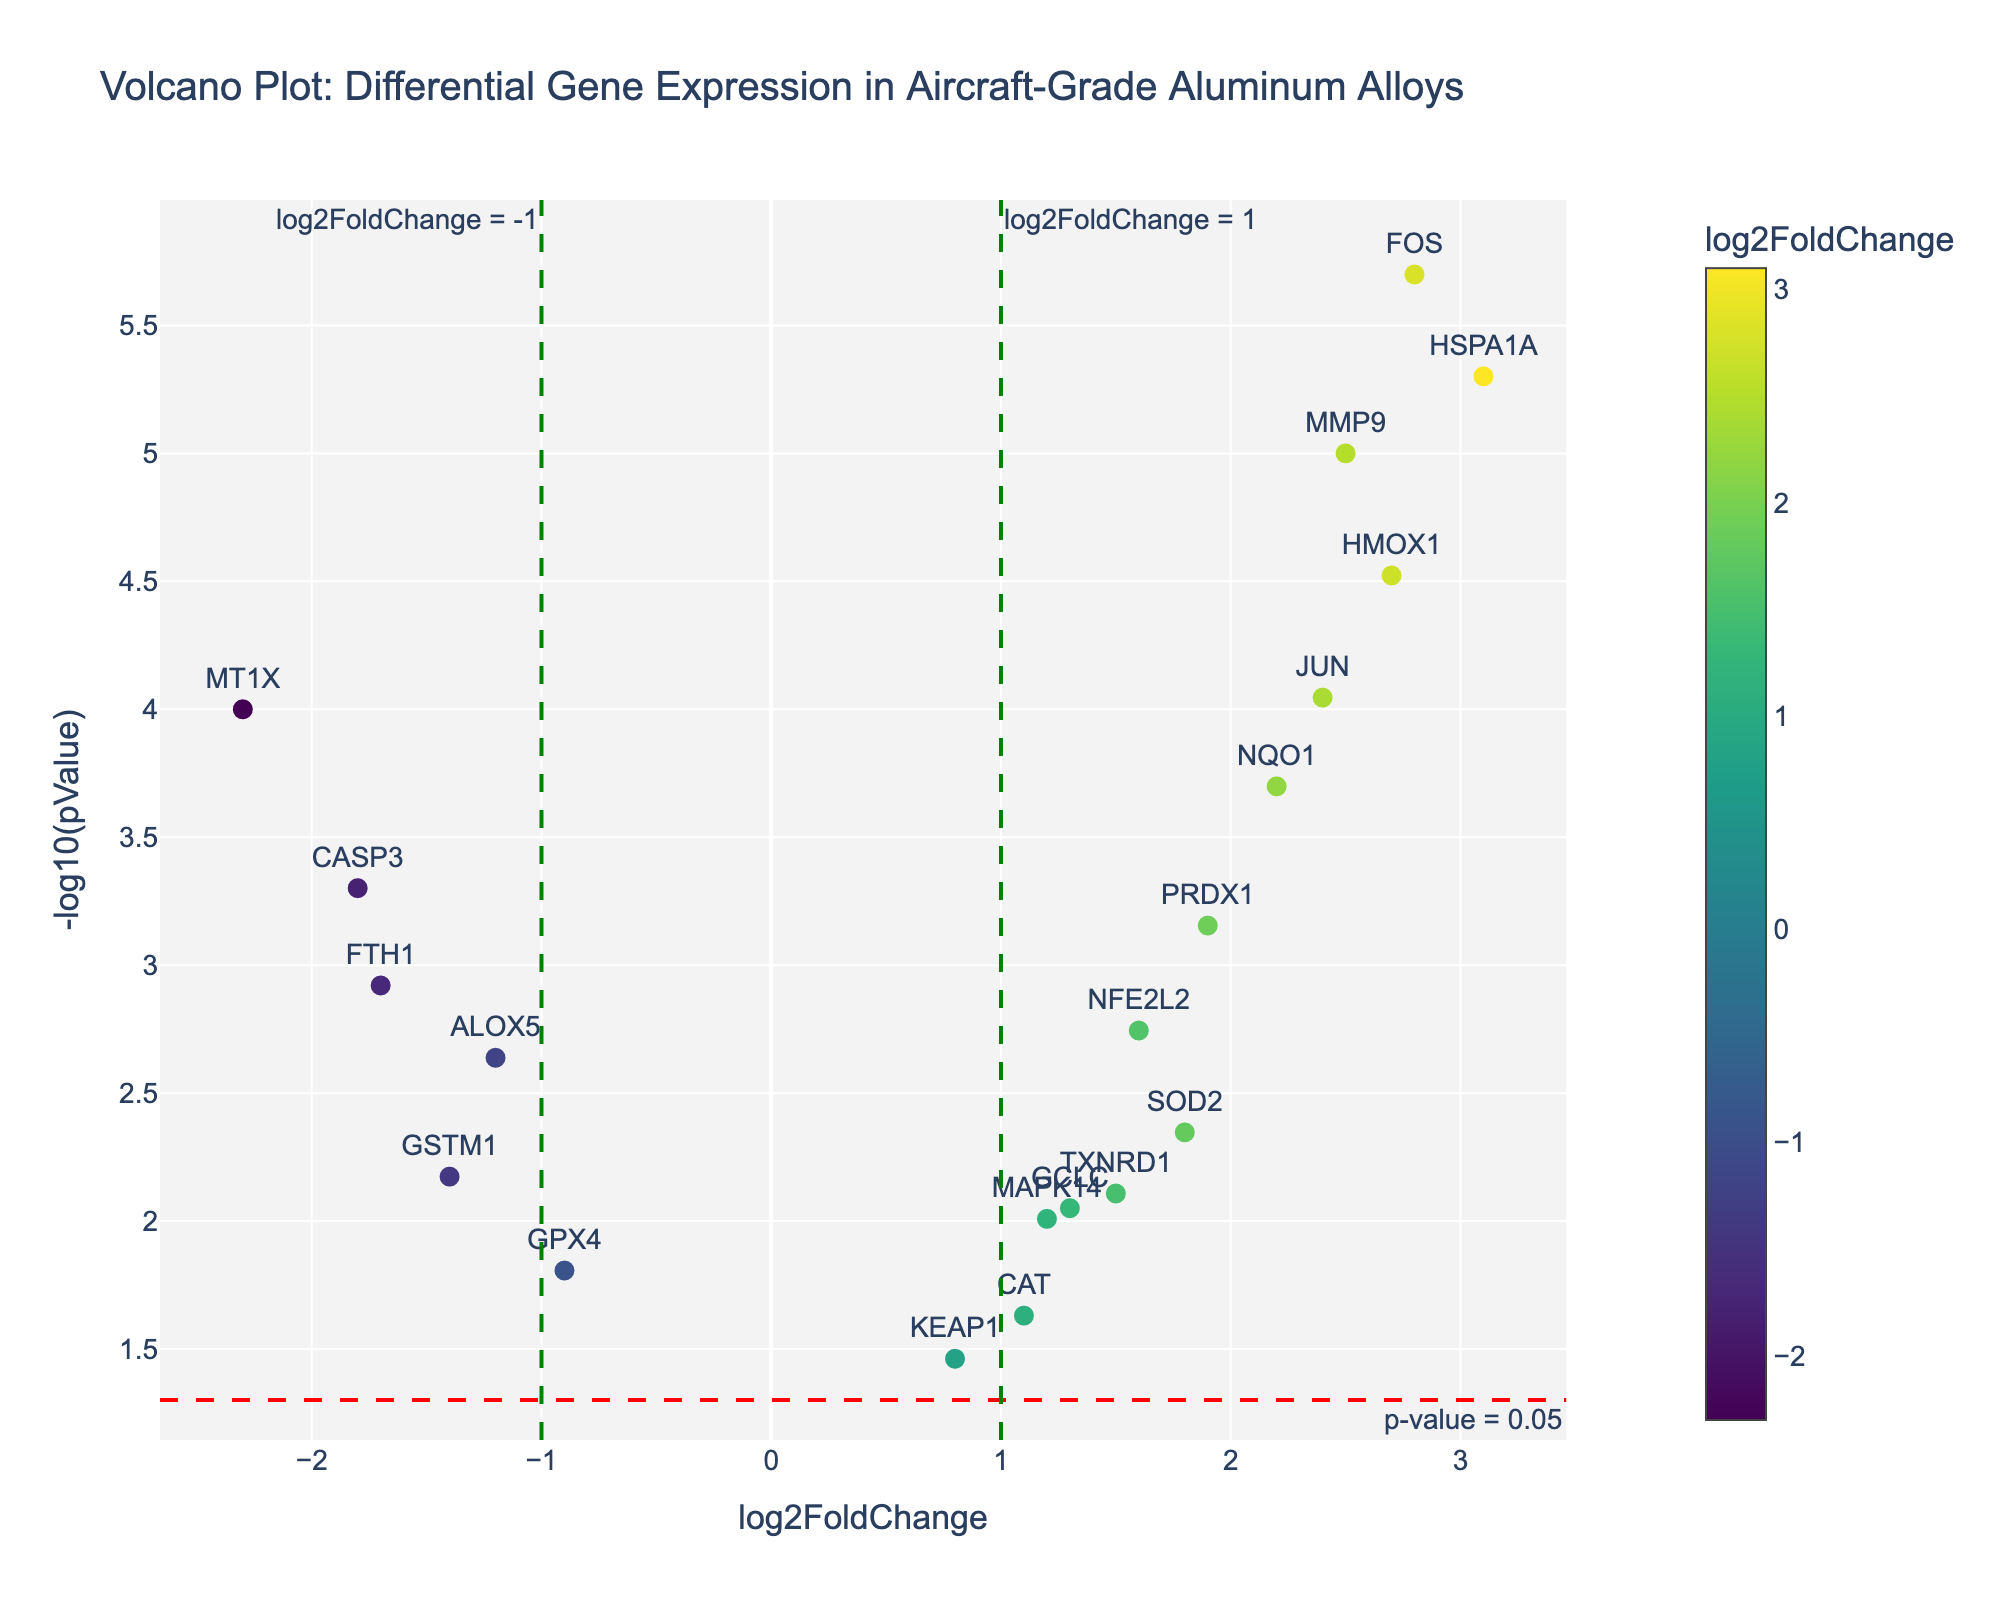What is the title of the plot? The title of the plot is usually located at the top center of the figure. In this case, it reads "Volcano Plot: Differential Gene Expression in Aircraft-Grade Aluminum Alloys".
Answer: Volcano Plot: Differential Gene Expression in Aircraft-Grade Aluminum Alloys What does the x-axis represent? The x-axis is labeled at the bottom of the figure. It represents "log2FoldChange", which indicates the logarithmic fold change in gene expression.
Answer: log2FoldChange What does the y-axis represent? The y-axis is labeled on the left side of the figure. It represents "-log10(pValue)", which indicates the negative logarithm of the p-value.
Answer: -log10(pValue) How many genes have a log2FoldChange greater than 2? By visually inspecting the plot, count the number of data points that are positioned to the right of the x = 2 line. The genes HSPA1A and FOS are positioned there.
Answer: 2 Which gene has the highest -log10(pValue)? By looking at the y-axis and identifying the data point furthest up, the gene with the highest -log10(pValue) can be determined. HSPA1A is the gene highest on the y-axis.
Answer: HSPA1A What is the range of log2FoldChange values present in the plot? To determine the range, identify the minimum and maximum log2FoldChange values represented on the x-axis. The minimum value is approximately -2.3 (from MT1X) and the maximum is approximately 3.1 (from HSPA1A).
Answer: -2.3 to 3.1 How many genes have a p-value less than 0.05? The horizontal threshold line representing p-value = 0.05 helps in identifying the genes below this significance level. Count the number of data points above this line. There are 14 such genes.
Answer: 14 Which genes have a negative log2FoldChange and a significant p-value (<0.05)? Identify the points left of the x = 0 line (negative log2FoldChange) and above the horizontal threshold line for p-value = 0.05. These genes are ALOX5, MT1X, FTH1, and CASP3.
Answer: ALOX5, MT1X, FTH1, CASP3 Among the genes with positive log2FoldChange, which one has the lowest -log10(pValue)? Focusing on the right side of the plot (positive log2FoldChange), identify the data point that is closest to the baseline of the y-axis. KEAP1 has the lowest -log10(pValue) among those genes with positive log2FoldChange.
Answer: KEAP1 